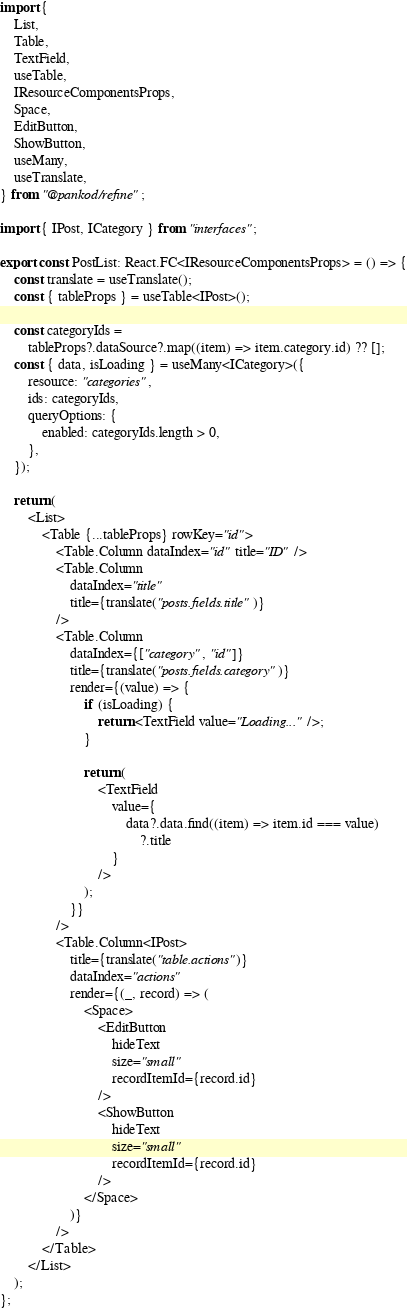<code> <loc_0><loc_0><loc_500><loc_500><_TypeScript_>import {
    List,
    Table,
    TextField,
    useTable,
    IResourceComponentsProps,
    Space,
    EditButton,
    ShowButton,
    useMany,
    useTranslate,
} from "@pankod/refine";

import { IPost, ICategory } from "interfaces";

export const PostList: React.FC<IResourceComponentsProps> = () => {
    const translate = useTranslate();
    const { tableProps } = useTable<IPost>();

    const categoryIds =
        tableProps?.dataSource?.map((item) => item.category.id) ?? [];
    const { data, isLoading } = useMany<ICategory>({
        resource: "categories",
        ids: categoryIds,
        queryOptions: {
            enabled: categoryIds.length > 0,
        },
    });

    return (
        <List>
            <Table {...tableProps} rowKey="id">
                <Table.Column dataIndex="id" title="ID" />
                <Table.Column
                    dataIndex="title"
                    title={translate("posts.fields.title")}
                />
                <Table.Column
                    dataIndex={["category", "id"]}
                    title={translate("posts.fields.category")}
                    render={(value) => {
                        if (isLoading) {
                            return <TextField value="Loading..." />;
                        }

                        return (
                            <TextField
                                value={
                                    data?.data.find((item) => item.id === value)
                                        ?.title
                                }
                            />
                        );
                    }}
                />
                <Table.Column<IPost>
                    title={translate("table.actions")}
                    dataIndex="actions"
                    render={(_, record) => (
                        <Space>
                            <EditButton
                                hideText
                                size="small"
                                recordItemId={record.id}
                            />
                            <ShowButton
                                hideText
                                size="small"
                                recordItemId={record.id}
                            />
                        </Space>
                    )}
                />
            </Table>
        </List>
    );
};
</code> 